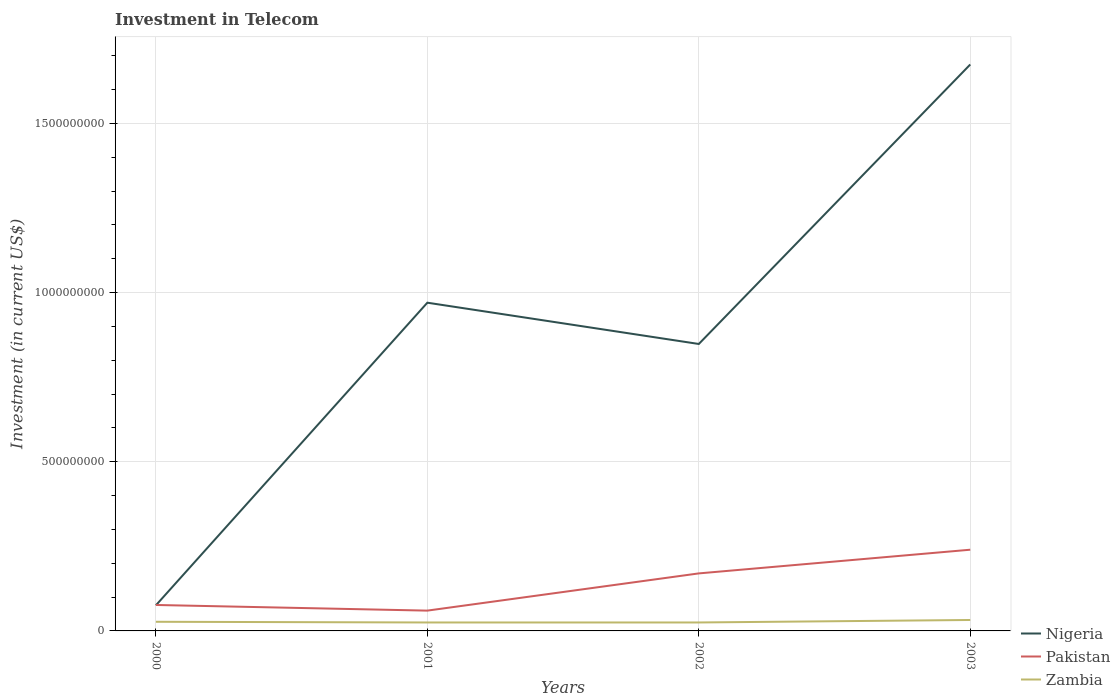How many different coloured lines are there?
Your answer should be very brief. 3. Across all years, what is the maximum amount invested in telecom in Pakistan?
Provide a short and direct response. 6.00e+07. What is the total amount invested in telecom in Zambia in the graph?
Offer a terse response. 2.00e+06. What is the difference between the highest and the second highest amount invested in telecom in Nigeria?
Your answer should be compact. 1.60e+09. Is the amount invested in telecom in Zambia strictly greater than the amount invested in telecom in Nigeria over the years?
Make the answer very short. Yes. What is the difference between two consecutive major ticks on the Y-axis?
Your answer should be very brief. 5.00e+08. Are the values on the major ticks of Y-axis written in scientific E-notation?
Offer a terse response. No. Does the graph contain grids?
Provide a short and direct response. Yes. How many legend labels are there?
Offer a terse response. 3. How are the legend labels stacked?
Your answer should be compact. Vertical. What is the title of the graph?
Offer a very short reply. Investment in Telecom. What is the label or title of the X-axis?
Offer a very short reply. Years. What is the label or title of the Y-axis?
Your response must be concise. Investment (in current US$). What is the Investment (in current US$) of Nigeria in 2000?
Offer a terse response. 7.57e+07. What is the Investment (in current US$) in Pakistan in 2000?
Ensure brevity in your answer.  7.67e+07. What is the Investment (in current US$) of Zambia in 2000?
Provide a succinct answer. 2.70e+07. What is the Investment (in current US$) of Nigeria in 2001?
Offer a terse response. 9.70e+08. What is the Investment (in current US$) of Pakistan in 2001?
Ensure brevity in your answer.  6.00e+07. What is the Investment (in current US$) of Zambia in 2001?
Give a very brief answer. 2.50e+07. What is the Investment (in current US$) in Nigeria in 2002?
Give a very brief answer. 8.48e+08. What is the Investment (in current US$) of Pakistan in 2002?
Offer a terse response. 1.70e+08. What is the Investment (in current US$) of Zambia in 2002?
Your answer should be very brief. 2.50e+07. What is the Investment (in current US$) of Nigeria in 2003?
Your answer should be very brief. 1.67e+09. What is the Investment (in current US$) in Pakistan in 2003?
Your response must be concise. 2.40e+08. What is the Investment (in current US$) in Zambia in 2003?
Your response must be concise. 3.23e+07. Across all years, what is the maximum Investment (in current US$) of Nigeria?
Provide a succinct answer. 1.67e+09. Across all years, what is the maximum Investment (in current US$) in Pakistan?
Keep it short and to the point. 2.40e+08. Across all years, what is the maximum Investment (in current US$) of Zambia?
Your answer should be compact. 3.23e+07. Across all years, what is the minimum Investment (in current US$) in Nigeria?
Give a very brief answer. 7.57e+07. Across all years, what is the minimum Investment (in current US$) in Pakistan?
Offer a very short reply. 6.00e+07. Across all years, what is the minimum Investment (in current US$) in Zambia?
Your answer should be very brief. 2.50e+07. What is the total Investment (in current US$) of Nigeria in the graph?
Make the answer very short. 3.57e+09. What is the total Investment (in current US$) of Pakistan in the graph?
Ensure brevity in your answer.  5.47e+08. What is the total Investment (in current US$) in Zambia in the graph?
Your answer should be compact. 1.09e+08. What is the difference between the Investment (in current US$) of Nigeria in 2000 and that in 2001?
Provide a short and direct response. -8.94e+08. What is the difference between the Investment (in current US$) of Pakistan in 2000 and that in 2001?
Offer a terse response. 1.67e+07. What is the difference between the Investment (in current US$) in Zambia in 2000 and that in 2001?
Make the answer very short. 2.00e+06. What is the difference between the Investment (in current US$) in Nigeria in 2000 and that in 2002?
Make the answer very short. -7.72e+08. What is the difference between the Investment (in current US$) in Pakistan in 2000 and that in 2002?
Provide a succinct answer. -9.33e+07. What is the difference between the Investment (in current US$) in Zambia in 2000 and that in 2002?
Make the answer very short. 2.00e+06. What is the difference between the Investment (in current US$) in Nigeria in 2000 and that in 2003?
Offer a very short reply. -1.60e+09. What is the difference between the Investment (in current US$) in Pakistan in 2000 and that in 2003?
Provide a short and direct response. -1.63e+08. What is the difference between the Investment (in current US$) in Zambia in 2000 and that in 2003?
Your answer should be very brief. -5.32e+06. What is the difference between the Investment (in current US$) of Nigeria in 2001 and that in 2002?
Ensure brevity in your answer.  1.22e+08. What is the difference between the Investment (in current US$) of Pakistan in 2001 and that in 2002?
Your answer should be very brief. -1.10e+08. What is the difference between the Investment (in current US$) in Zambia in 2001 and that in 2002?
Ensure brevity in your answer.  0. What is the difference between the Investment (in current US$) in Nigeria in 2001 and that in 2003?
Ensure brevity in your answer.  -7.04e+08. What is the difference between the Investment (in current US$) in Pakistan in 2001 and that in 2003?
Your response must be concise. -1.80e+08. What is the difference between the Investment (in current US$) in Zambia in 2001 and that in 2003?
Offer a very short reply. -7.32e+06. What is the difference between the Investment (in current US$) in Nigeria in 2002 and that in 2003?
Your answer should be very brief. -8.26e+08. What is the difference between the Investment (in current US$) of Pakistan in 2002 and that in 2003?
Give a very brief answer. -7.00e+07. What is the difference between the Investment (in current US$) in Zambia in 2002 and that in 2003?
Ensure brevity in your answer.  -7.32e+06. What is the difference between the Investment (in current US$) in Nigeria in 2000 and the Investment (in current US$) in Pakistan in 2001?
Give a very brief answer. 1.57e+07. What is the difference between the Investment (in current US$) of Nigeria in 2000 and the Investment (in current US$) of Zambia in 2001?
Your answer should be compact. 5.07e+07. What is the difference between the Investment (in current US$) of Pakistan in 2000 and the Investment (in current US$) of Zambia in 2001?
Your response must be concise. 5.17e+07. What is the difference between the Investment (in current US$) in Nigeria in 2000 and the Investment (in current US$) in Pakistan in 2002?
Keep it short and to the point. -9.43e+07. What is the difference between the Investment (in current US$) of Nigeria in 2000 and the Investment (in current US$) of Zambia in 2002?
Ensure brevity in your answer.  5.07e+07. What is the difference between the Investment (in current US$) of Pakistan in 2000 and the Investment (in current US$) of Zambia in 2002?
Offer a very short reply. 5.17e+07. What is the difference between the Investment (in current US$) in Nigeria in 2000 and the Investment (in current US$) in Pakistan in 2003?
Your answer should be very brief. -1.64e+08. What is the difference between the Investment (in current US$) in Nigeria in 2000 and the Investment (in current US$) in Zambia in 2003?
Your answer should be compact. 4.34e+07. What is the difference between the Investment (in current US$) of Pakistan in 2000 and the Investment (in current US$) of Zambia in 2003?
Your response must be concise. 4.44e+07. What is the difference between the Investment (in current US$) of Nigeria in 2001 and the Investment (in current US$) of Pakistan in 2002?
Offer a very short reply. 8.00e+08. What is the difference between the Investment (in current US$) in Nigeria in 2001 and the Investment (in current US$) in Zambia in 2002?
Ensure brevity in your answer.  9.45e+08. What is the difference between the Investment (in current US$) in Pakistan in 2001 and the Investment (in current US$) in Zambia in 2002?
Make the answer very short. 3.50e+07. What is the difference between the Investment (in current US$) of Nigeria in 2001 and the Investment (in current US$) of Pakistan in 2003?
Give a very brief answer. 7.30e+08. What is the difference between the Investment (in current US$) of Nigeria in 2001 and the Investment (in current US$) of Zambia in 2003?
Offer a terse response. 9.38e+08. What is the difference between the Investment (in current US$) of Pakistan in 2001 and the Investment (in current US$) of Zambia in 2003?
Your response must be concise. 2.77e+07. What is the difference between the Investment (in current US$) in Nigeria in 2002 and the Investment (in current US$) in Pakistan in 2003?
Give a very brief answer. 6.08e+08. What is the difference between the Investment (in current US$) of Nigeria in 2002 and the Investment (in current US$) of Zambia in 2003?
Give a very brief answer. 8.16e+08. What is the difference between the Investment (in current US$) of Pakistan in 2002 and the Investment (in current US$) of Zambia in 2003?
Your answer should be very brief. 1.38e+08. What is the average Investment (in current US$) of Nigeria per year?
Give a very brief answer. 8.92e+08. What is the average Investment (in current US$) of Pakistan per year?
Give a very brief answer. 1.37e+08. What is the average Investment (in current US$) in Zambia per year?
Give a very brief answer. 2.73e+07. In the year 2000, what is the difference between the Investment (in current US$) of Nigeria and Investment (in current US$) of Zambia?
Your answer should be compact. 4.87e+07. In the year 2000, what is the difference between the Investment (in current US$) in Pakistan and Investment (in current US$) in Zambia?
Offer a very short reply. 4.97e+07. In the year 2001, what is the difference between the Investment (in current US$) in Nigeria and Investment (in current US$) in Pakistan?
Keep it short and to the point. 9.10e+08. In the year 2001, what is the difference between the Investment (in current US$) in Nigeria and Investment (in current US$) in Zambia?
Your answer should be very brief. 9.45e+08. In the year 2001, what is the difference between the Investment (in current US$) in Pakistan and Investment (in current US$) in Zambia?
Your answer should be compact. 3.50e+07. In the year 2002, what is the difference between the Investment (in current US$) in Nigeria and Investment (in current US$) in Pakistan?
Make the answer very short. 6.78e+08. In the year 2002, what is the difference between the Investment (in current US$) in Nigeria and Investment (in current US$) in Zambia?
Keep it short and to the point. 8.23e+08. In the year 2002, what is the difference between the Investment (in current US$) of Pakistan and Investment (in current US$) of Zambia?
Ensure brevity in your answer.  1.45e+08. In the year 2003, what is the difference between the Investment (in current US$) of Nigeria and Investment (in current US$) of Pakistan?
Ensure brevity in your answer.  1.43e+09. In the year 2003, what is the difference between the Investment (in current US$) in Nigeria and Investment (in current US$) in Zambia?
Your answer should be compact. 1.64e+09. In the year 2003, what is the difference between the Investment (in current US$) of Pakistan and Investment (in current US$) of Zambia?
Give a very brief answer. 2.08e+08. What is the ratio of the Investment (in current US$) of Nigeria in 2000 to that in 2001?
Offer a terse response. 0.08. What is the ratio of the Investment (in current US$) of Pakistan in 2000 to that in 2001?
Provide a short and direct response. 1.28. What is the ratio of the Investment (in current US$) of Zambia in 2000 to that in 2001?
Your answer should be very brief. 1.08. What is the ratio of the Investment (in current US$) in Nigeria in 2000 to that in 2002?
Ensure brevity in your answer.  0.09. What is the ratio of the Investment (in current US$) in Pakistan in 2000 to that in 2002?
Provide a succinct answer. 0.45. What is the ratio of the Investment (in current US$) in Nigeria in 2000 to that in 2003?
Offer a terse response. 0.05. What is the ratio of the Investment (in current US$) in Pakistan in 2000 to that in 2003?
Provide a short and direct response. 0.32. What is the ratio of the Investment (in current US$) in Zambia in 2000 to that in 2003?
Your response must be concise. 0.84. What is the ratio of the Investment (in current US$) in Nigeria in 2001 to that in 2002?
Ensure brevity in your answer.  1.14. What is the ratio of the Investment (in current US$) of Pakistan in 2001 to that in 2002?
Make the answer very short. 0.35. What is the ratio of the Investment (in current US$) of Zambia in 2001 to that in 2002?
Give a very brief answer. 1. What is the ratio of the Investment (in current US$) in Nigeria in 2001 to that in 2003?
Provide a succinct answer. 0.58. What is the ratio of the Investment (in current US$) of Zambia in 2001 to that in 2003?
Provide a short and direct response. 0.77. What is the ratio of the Investment (in current US$) of Nigeria in 2002 to that in 2003?
Your answer should be compact. 0.51. What is the ratio of the Investment (in current US$) in Pakistan in 2002 to that in 2003?
Offer a terse response. 0.71. What is the ratio of the Investment (in current US$) in Zambia in 2002 to that in 2003?
Provide a succinct answer. 0.77. What is the difference between the highest and the second highest Investment (in current US$) in Nigeria?
Give a very brief answer. 7.04e+08. What is the difference between the highest and the second highest Investment (in current US$) of Pakistan?
Provide a succinct answer. 7.00e+07. What is the difference between the highest and the second highest Investment (in current US$) in Zambia?
Provide a succinct answer. 5.32e+06. What is the difference between the highest and the lowest Investment (in current US$) of Nigeria?
Your answer should be compact. 1.60e+09. What is the difference between the highest and the lowest Investment (in current US$) in Pakistan?
Provide a short and direct response. 1.80e+08. What is the difference between the highest and the lowest Investment (in current US$) of Zambia?
Make the answer very short. 7.32e+06. 